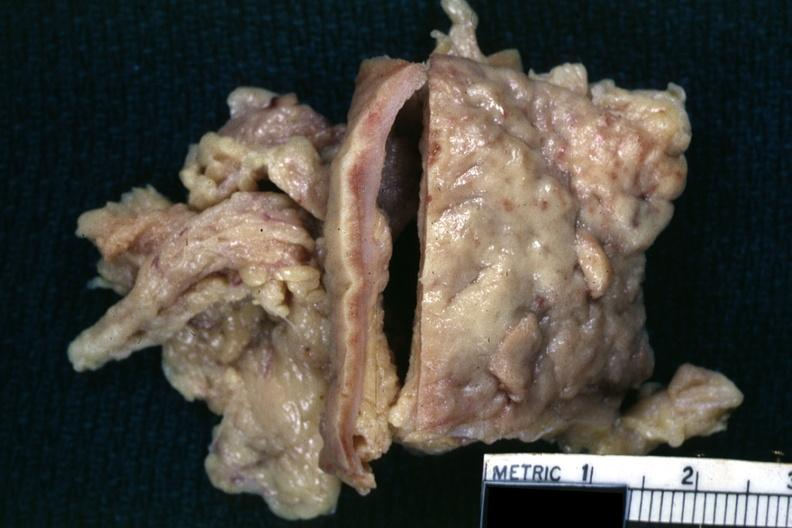s omphalocele present?
Answer the question using a single word or phrase. No 